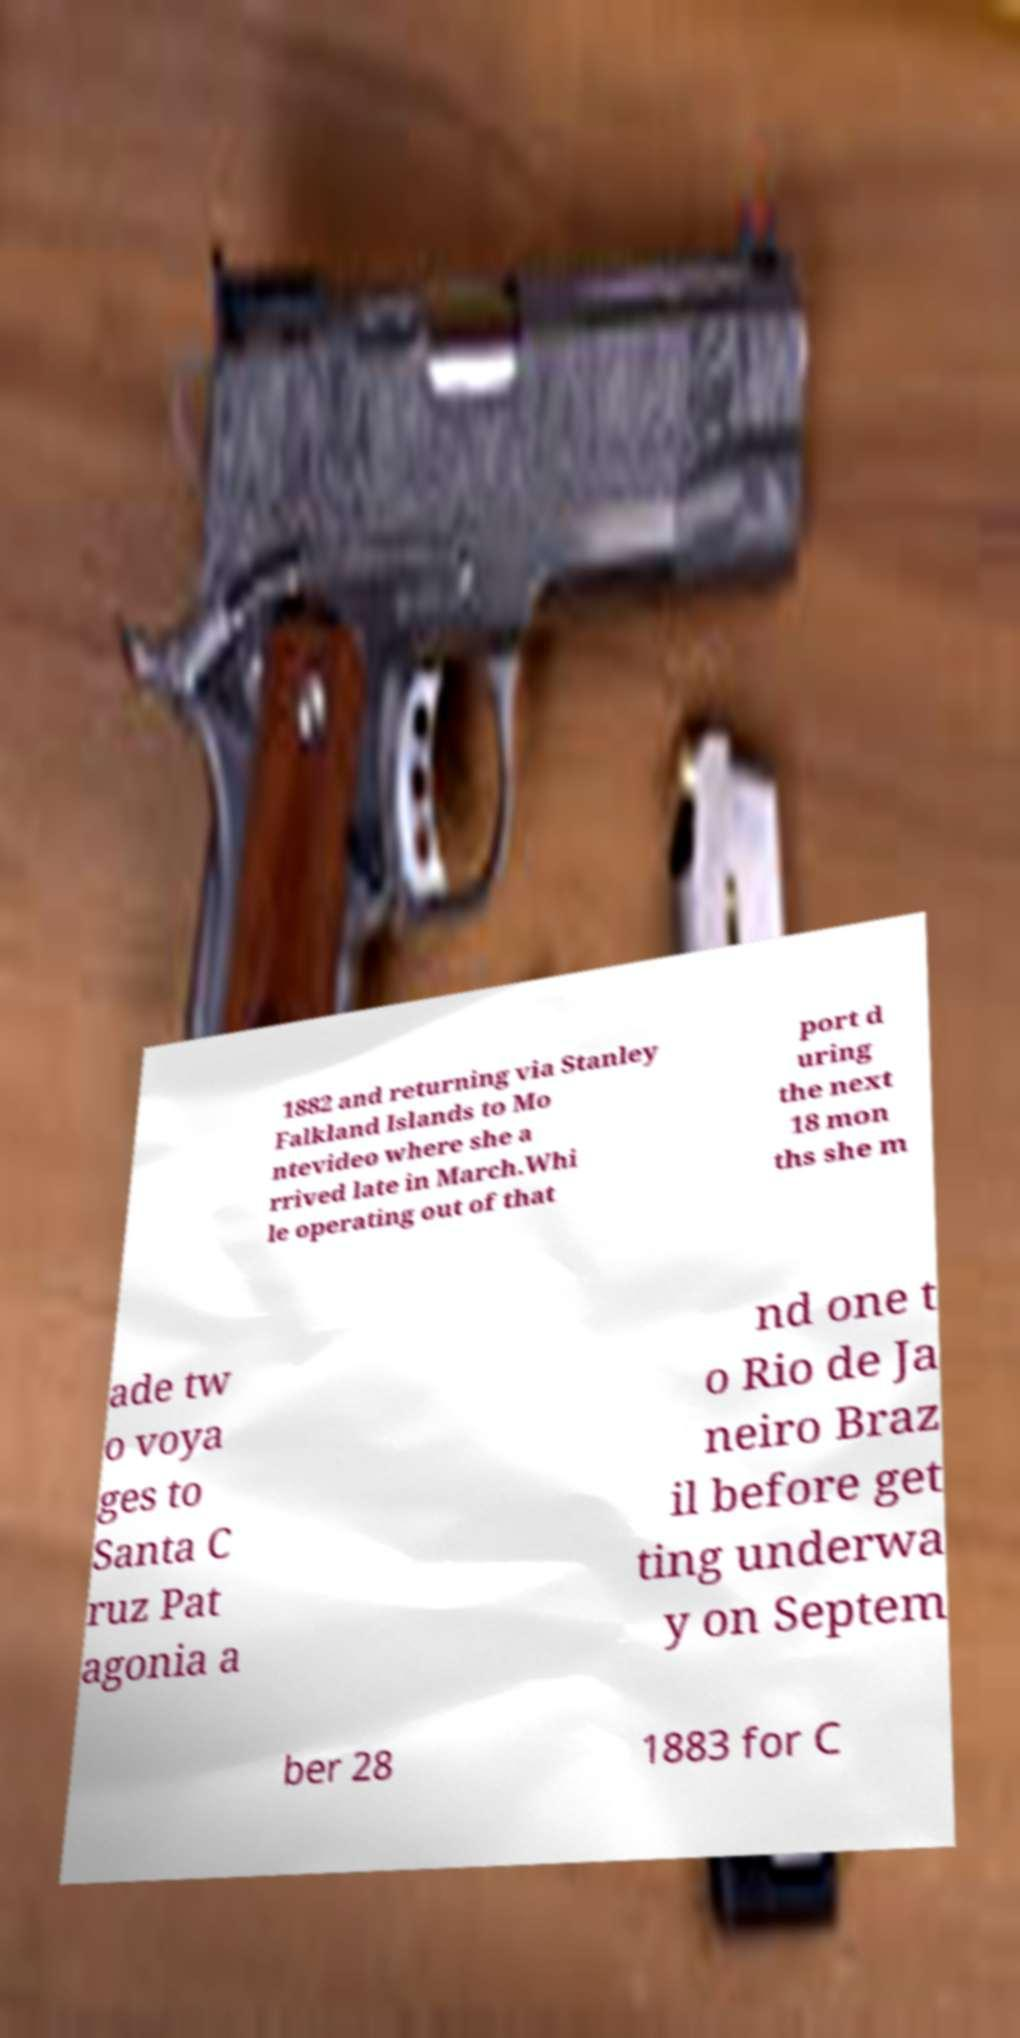Can you read and provide the text displayed in the image?This photo seems to have some interesting text. Can you extract and type it out for me? 1882 and returning via Stanley Falkland Islands to Mo ntevideo where she a rrived late in March.Whi le operating out of that port d uring the next 18 mon ths she m ade tw o voya ges to Santa C ruz Pat agonia a nd one t o Rio de Ja neiro Braz il before get ting underwa y on Septem ber 28 1883 for C 